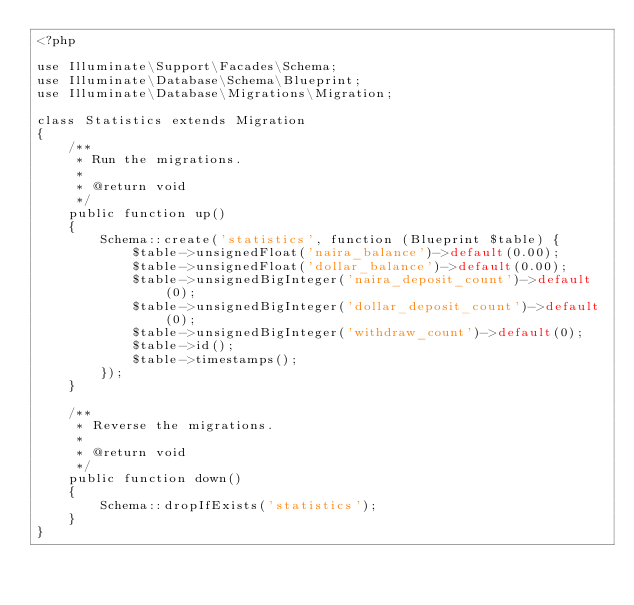<code> <loc_0><loc_0><loc_500><loc_500><_PHP_><?php

use Illuminate\Support\Facades\Schema;
use Illuminate\Database\Schema\Blueprint;
use Illuminate\Database\Migrations\Migration;

class Statistics extends Migration
{
    /**
     * Run the migrations.
     *
     * @return void
     */
    public function up()
    {
        Schema::create('statistics', function (Blueprint $table) {
            $table->unsignedFloat('naira_balance')->default(0.00);
            $table->unsignedFloat('dollar_balance')->default(0.00);
            $table->unsignedBigInteger('naira_deposit_count')->default(0);
            $table->unsignedBigInteger('dollar_deposit_count')->default(0);
            $table->unsignedBigInteger('withdraw_count')->default(0);
            $table->id();
            $table->timestamps();
        });
    }

    /**
     * Reverse the migrations.
     *
     * @return void
     */
    public function down()
    {
        Schema::dropIfExists('statistics');
    }
}
</code> 